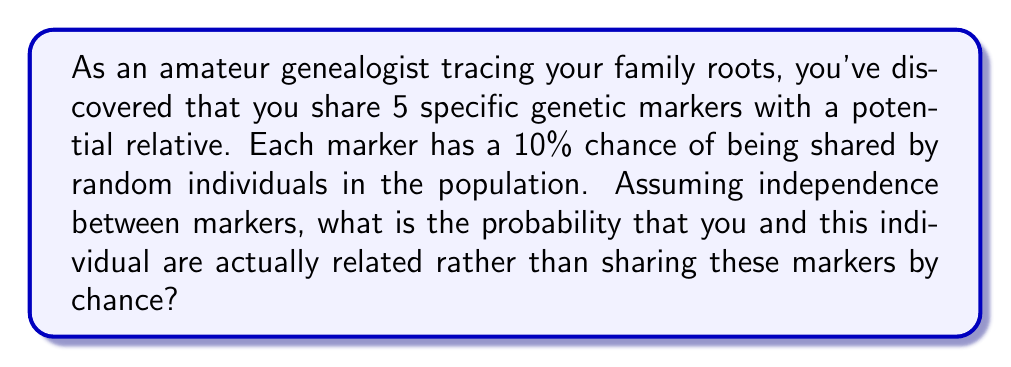Teach me how to tackle this problem. Let's approach this step-by-step:

1) First, we need to calculate the probability of sharing all 5 markers by chance:
   - For each marker, the probability is 10% or 0.1
   - With 5 independent markers, we multiply these probabilities:
   $$ P(\text{sharing by chance}) = 0.1^5 = 0.00001 $$

2) Now, let's consider the complement of this probability:
   $$ P(\text{not sharing by chance}) = 1 - 0.00001 = 0.99999 $$

3) This complement probability represents the likelihood that the shared markers are due to relation rather than chance.

4) To express this as a percentage, we multiply by 100:
   $$ 0.99999 \times 100 = 99.999\% $$

5) This high probability suggests a very strong likelihood of relation, which is consistent with what we'd expect in genealogical research when multiple specific genetic markers are shared.
Answer: 99.999% 